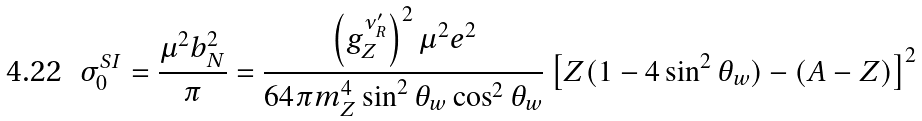<formula> <loc_0><loc_0><loc_500><loc_500>\sigma _ { 0 } ^ { S I } = \frac { \mu ^ { 2 } b _ { N } ^ { 2 } } { \pi } = \frac { \left ( g _ { Z } ^ { \nu ^ { \prime } _ { R } } \right ) ^ { 2 } \mu ^ { 2 } e ^ { 2 } } { 6 4 \pi m _ { Z } ^ { 4 } \sin ^ { 2 } \theta _ { w } \cos ^ { 2 } \theta _ { w } } \left [ Z ( 1 - 4 \sin ^ { 2 } \theta _ { w } ) - ( A - Z ) \right ] ^ { 2 }</formula> 